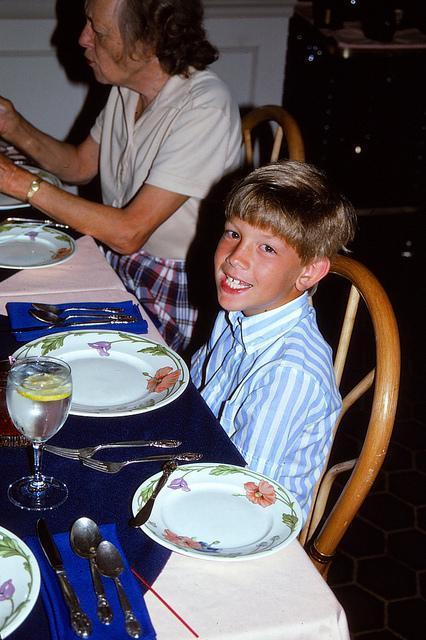How many chairs are visible?
Give a very brief answer. 2. How many people are in the picture?
Give a very brief answer. 2. 